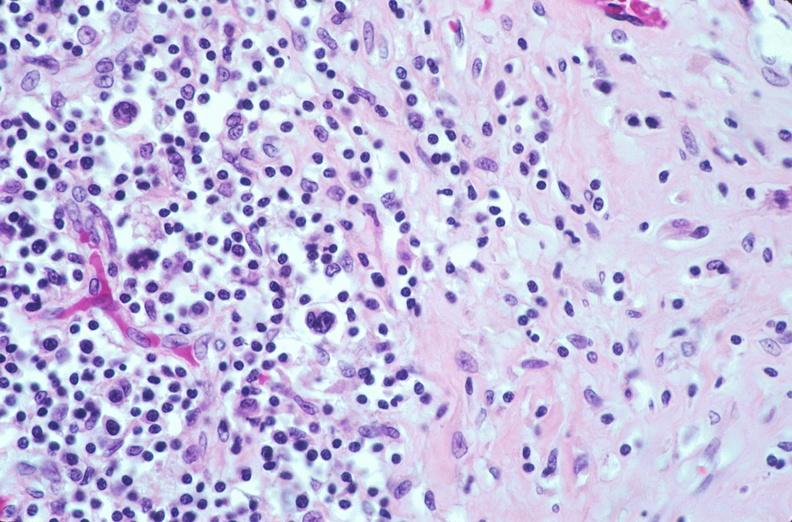does fracture show lymph nodes, nodular sclerosing hodgkins disease?
Answer the question using a single word or phrase. No 